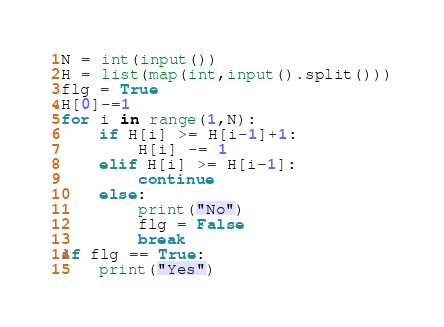<code> <loc_0><loc_0><loc_500><loc_500><_Python_>N = int(input())
H = list(map(int,input().split()))
flg = True
H[0]-=1
for i in range(1,N):
    if H[i] >= H[i-1]+1:
        H[i] -= 1
    elif H[i] >= H[i-1]:
        continue
    else:
        print("No")
        flg = False
        break
if flg == True:
    print("Yes")
</code> 